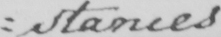Transcribe the text shown in this historical manuscript line. : stances 